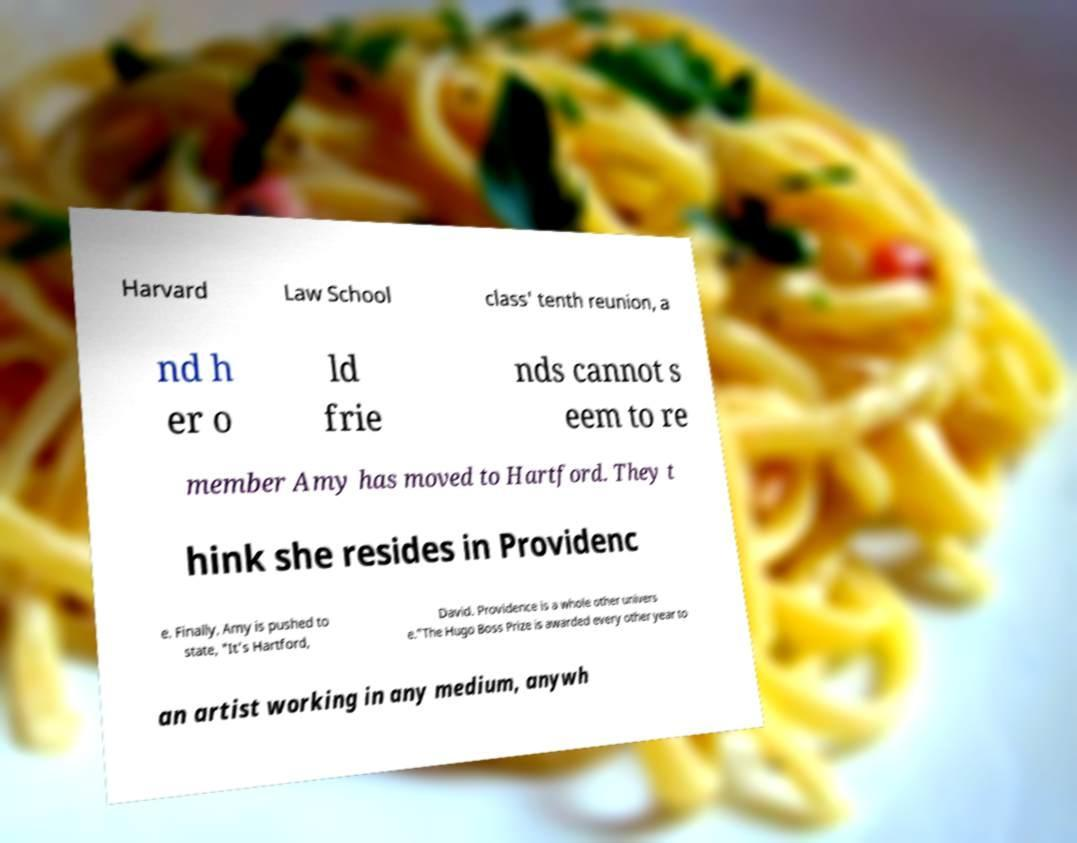Please read and relay the text visible in this image. What does it say? Harvard Law School class' tenth reunion, a nd h er o ld frie nds cannot s eem to re member Amy has moved to Hartford. They t hink she resides in Providenc e. Finally, Amy is pushed to state, "It's Hartford, David. Providence is a whole other univers e."The Hugo Boss Prize is awarded every other year to an artist working in any medium, anywh 